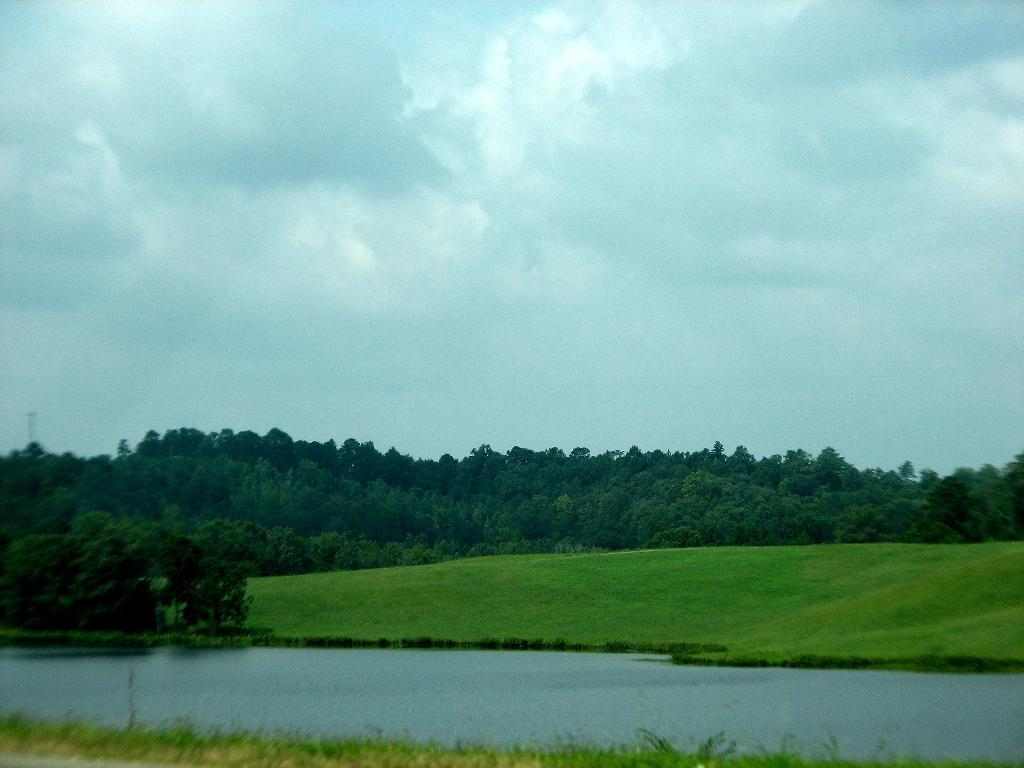What type of terrain is visible in the image? There is grass on the ground in the image. What else can be seen in the image besides grass? There is water, plants, trees, and a cloudy sky visible in the image. What color is the ink used to write on the ship in the image? There is no ship present in the image, so there is no ink or writing to consider. 